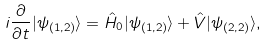<formula> <loc_0><loc_0><loc_500><loc_500>i \frac { \partial } { \partial t } | \psi _ { ( 1 , 2 ) } \rangle = \hat { H } _ { 0 } | \psi _ { ( 1 , 2 ) } \rangle + \hat { V } | \psi _ { ( 2 , 2 ) } \rangle , \</formula> 